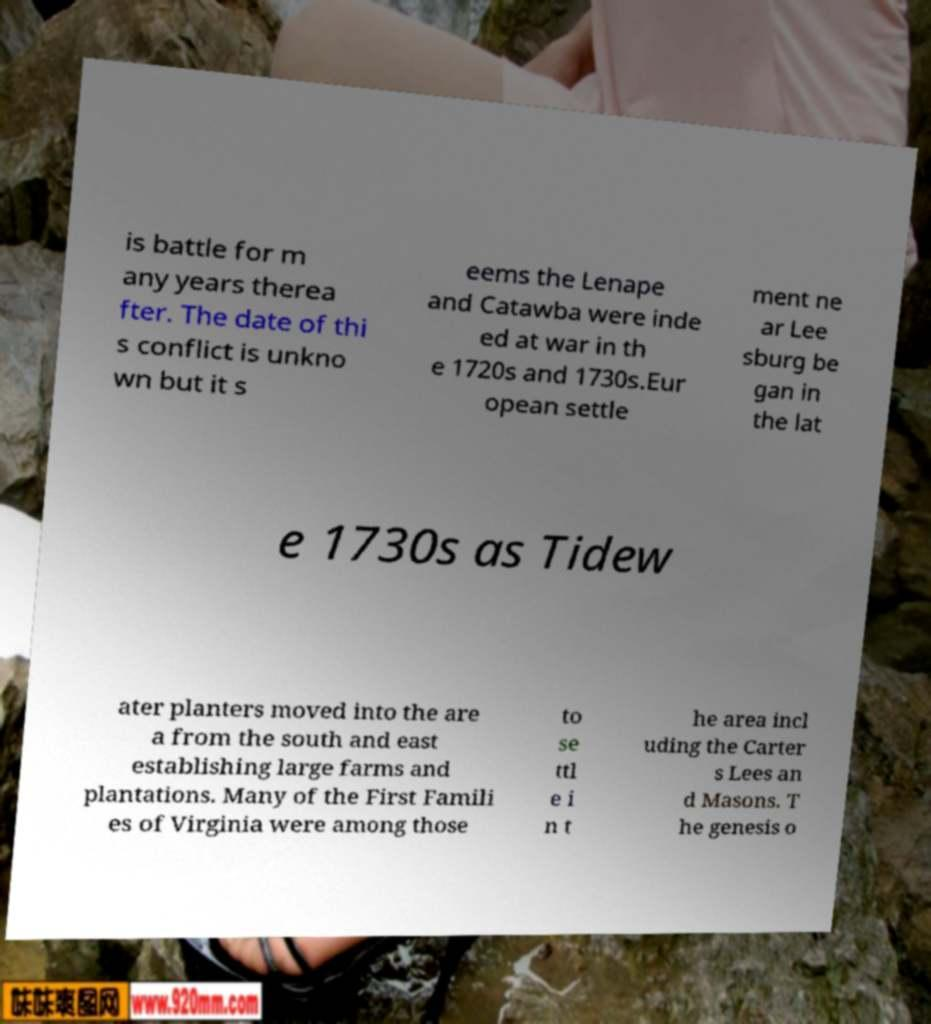Can you accurately transcribe the text from the provided image for me? is battle for m any years therea fter. The date of thi s conflict is unkno wn but it s eems the Lenape and Catawba were inde ed at war in th e 1720s and 1730s.Eur opean settle ment ne ar Lee sburg be gan in the lat e 1730s as Tidew ater planters moved into the are a from the south and east establishing large farms and plantations. Many of the First Famili es of Virginia were among those to se ttl e i n t he area incl uding the Carter s Lees an d Masons. T he genesis o 